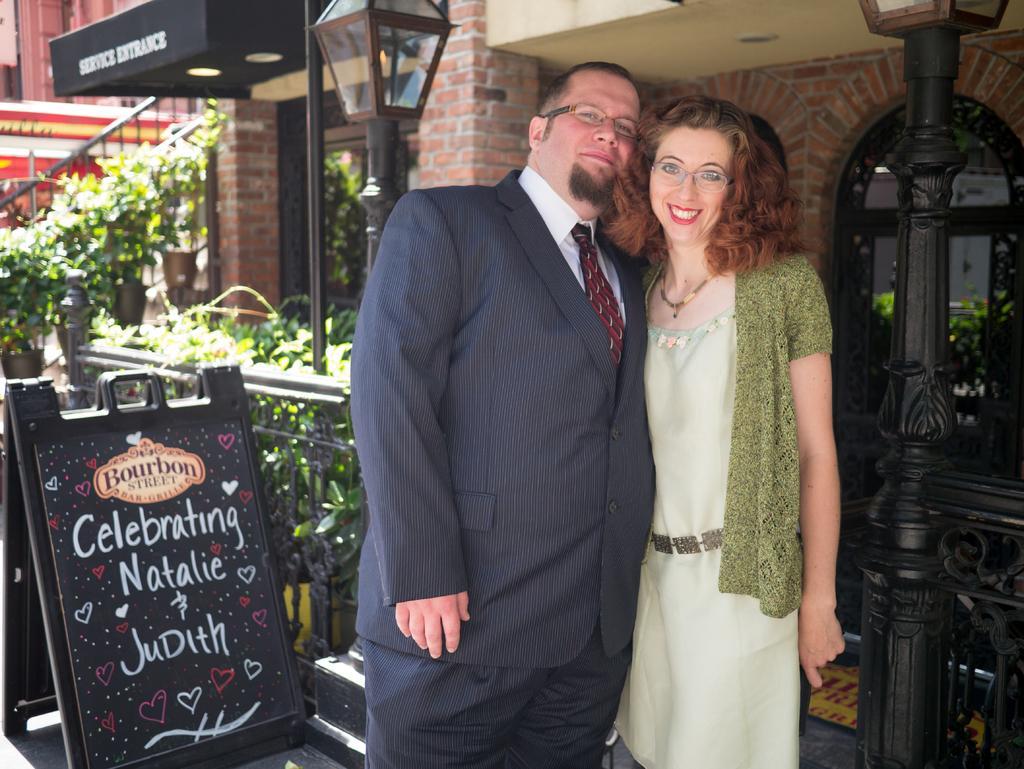Please provide a concise description of this image. In the middle of the image two persons are standing and smiling. Behind them there are some plants and fencing and poles. Bottom left side of the image there is a banner. Top of the image there are some buildings. 